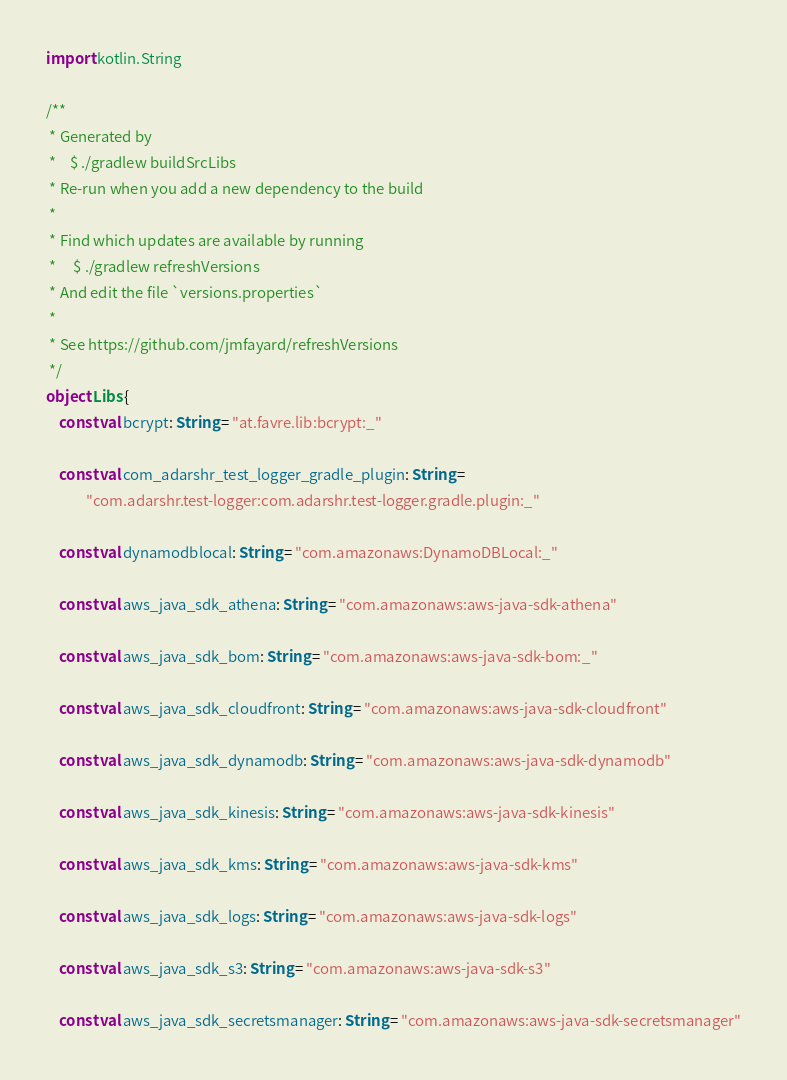<code> <loc_0><loc_0><loc_500><loc_500><_Kotlin_>import kotlin.String

/**
 * Generated by
 *    $ ./gradlew buildSrcLibs
 * Re-run when you add a new dependency to the build
 *
 * Find which updates are available by running
 *     $ ./gradlew refreshVersions
 * And edit the file `versions.properties`
 *
 * See https://github.com/jmfayard/refreshVersions
 */
object Libs {
    const val bcrypt: String = "at.favre.lib:bcrypt:_"

    const val com_adarshr_test_logger_gradle_plugin: String =
            "com.adarshr.test-logger:com.adarshr.test-logger.gradle.plugin:_"

    const val dynamodblocal: String = "com.amazonaws:DynamoDBLocal:_"

    const val aws_java_sdk_athena: String = "com.amazonaws:aws-java-sdk-athena"

    const val aws_java_sdk_bom: String = "com.amazonaws:aws-java-sdk-bom:_"

    const val aws_java_sdk_cloudfront: String = "com.amazonaws:aws-java-sdk-cloudfront"

    const val aws_java_sdk_dynamodb: String = "com.amazonaws:aws-java-sdk-dynamodb"

    const val aws_java_sdk_kinesis: String = "com.amazonaws:aws-java-sdk-kinesis"

    const val aws_java_sdk_kms: String = "com.amazonaws:aws-java-sdk-kms"

    const val aws_java_sdk_logs: String = "com.amazonaws:aws-java-sdk-logs"

    const val aws_java_sdk_s3: String = "com.amazonaws:aws-java-sdk-s3"

    const val aws_java_sdk_secretsmanager: String = "com.amazonaws:aws-java-sdk-secretsmanager"
</code> 